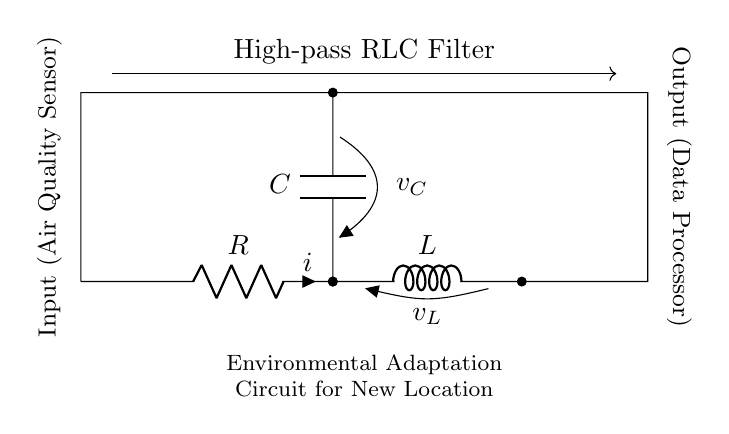What is the type of filter represented in this circuit? The circuit is identified as a high-pass RLC filter due to the arrangement of the resistive, inductive, and capacitive components that allows high frequencies to pass while attenuating low frequencies.
Answer: High-pass RLC filter Which component has the symbol 'C'? The component marked with 'C' represents a capacitor in the circuit diagram. A capacitor is used here to create the high-pass characteristic by blocking low-frequency signals from passing through.
Answer: Capacitor What is the role of 'R' in this circuit? The 'R' indicates a resistor, which is part of the circuit that controls the flow of current and adds resistance to the circuit. This resistance is essential in conjunction with the inductor and capacitor for determining the cutoff frequency of the filter.
Answer: Resistor How many components are in this circuit? The circuit contains three primary components: a resistor, an inductor, and a capacitor. These three elements work together to form a high-pass filter.
Answer: Three What does 'v_L' represent in this diagram? 'v_L' indicates the voltage across the inductor ('L') in the circuit. This voltage is significant for understanding how the inductor behaves in response to changing current and frequency.
Answer: Voltage across the inductor What is the function of the inductor ('L') in this RLC filter? The inductor ('L') stores energy in a magnetic field when current flows through it and essentially allows the circuit to oppose changes in current. This property helps in filtering out higher frequency signals while enabling lower frequencies to pass.
Answer: Opposes changes in current What is the expected output of this high-pass RLC filter? The output of the circuit processes signals that primarily consist of higher frequencies, effectively filtering out lower frequency noise or signals in the data collected from the air quality sensor to enhance environmental monitoring.
Answer: Higher frequencies 